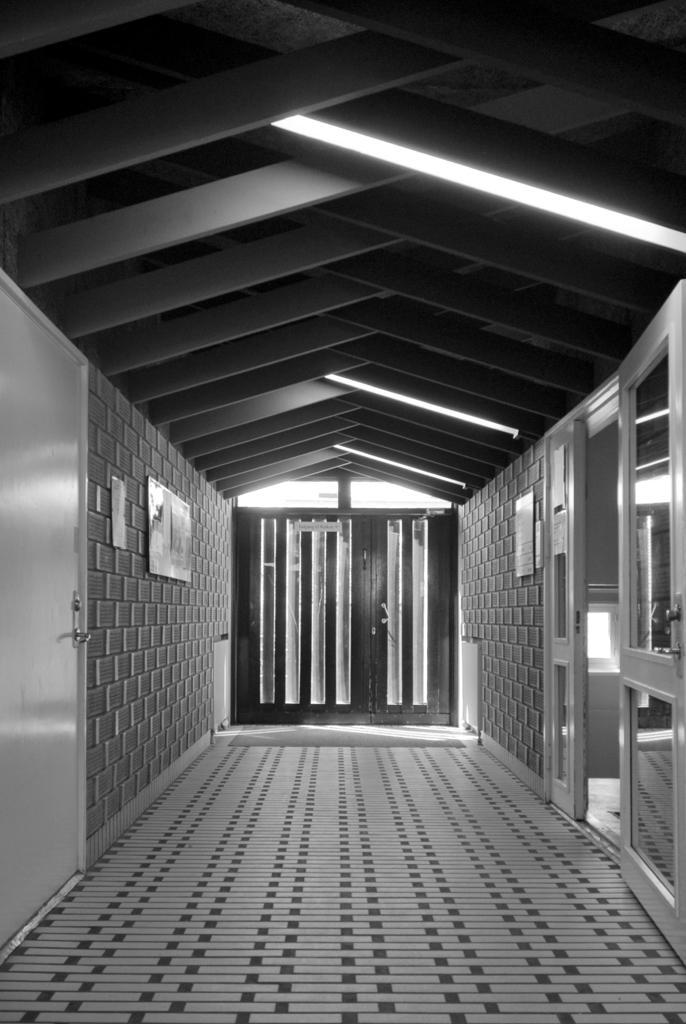How would you summarize this image in a sentence or two? In the picture we can see inside the house with walls and other room doors on the either sides and in the background, we can see a door and to the ceiling we can see the lights. 